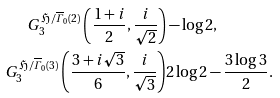Convert formula to latex. <formula><loc_0><loc_0><loc_500><loc_500>G _ { 3 } ^ { \mathfrak H / \overline { \varGamma } _ { 0 } ( 2 ) } \left ( \frac { 1 + i } { 2 } , \frac { i } { \sqrt { 2 } } \right ) & - \log 2 , \\ G _ { 3 } ^ { \mathfrak H / \overline { \varGamma } _ { 0 } ( 3 ) } \left ( \frac { 3 + i \sqrt { 3 } } { 6 } , \frac { i } { \sqrt { 3 } } \right ) & 2 \log 2 - \frac { 3 \log 3 } { 2 } .</formula> 